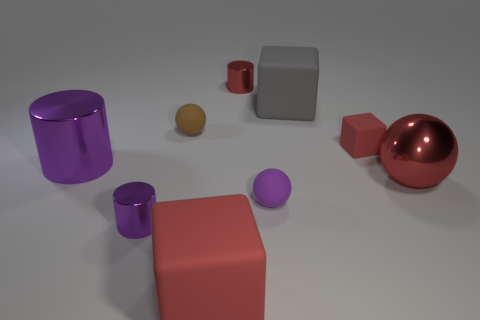Add 1 tiny red rubber blocks. How many objects exist? 10 Subtract all brown spheres. How many purple cylinders are left? 2 Subtract all large matte blocks. How many blocks are left? 1 Subtract 3 blocks. How many blocks are left? 0 Subtract all cylinders. How many objects are left? 6 Subtract all brown balls. How many balls are left? 2 Add 2 tiny yellow matte cubes. How many tiny yellow matte cubes exist? 2 Subtract 1 red cylinders. How many objects are left? 8 Subtract all yellow cylinders. Subtract all brown balls. How many cylinders are left? 3 Subtract all small rubber objects. Subtract all tiny purple metal cylinders. How many objects are left? 5 